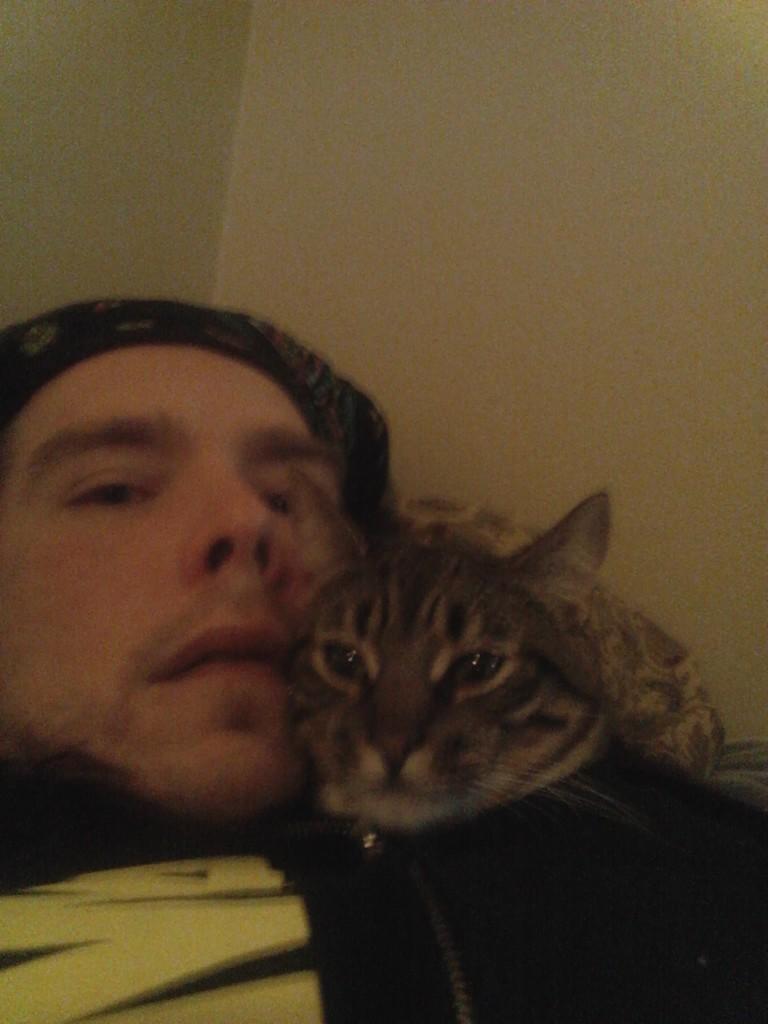Describe this image in one or two sentences. This image is taken inside a room. In this image a man is lying, he is wearing a cap and on top of him there is a cat. 